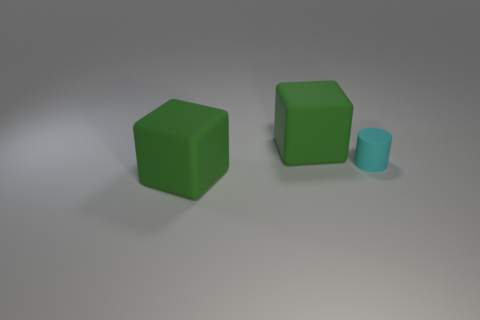Add 3 small gray cubes. How many objects exist? 6 Subtract all cylinders. How many objects are left? 2 Subtract 1 cylinders. How many cylinders are left? 0 Add 2 cyan rubber things. How many cyan rubber things exist? 3 Subtract 0 yellow blocks. How many objects are left? 3 Subtract all gray blocks. Subtract all yellow balls. How many blocks are left? 2 Subtract all cyan cylinders. How many brown blocks are left? 0 Subtract all tiny cylinders. Subtract all large rubber things. How many objects are left? 0 Add 1 small rubber cylinders. How many small rubber cylinders are left? 2 